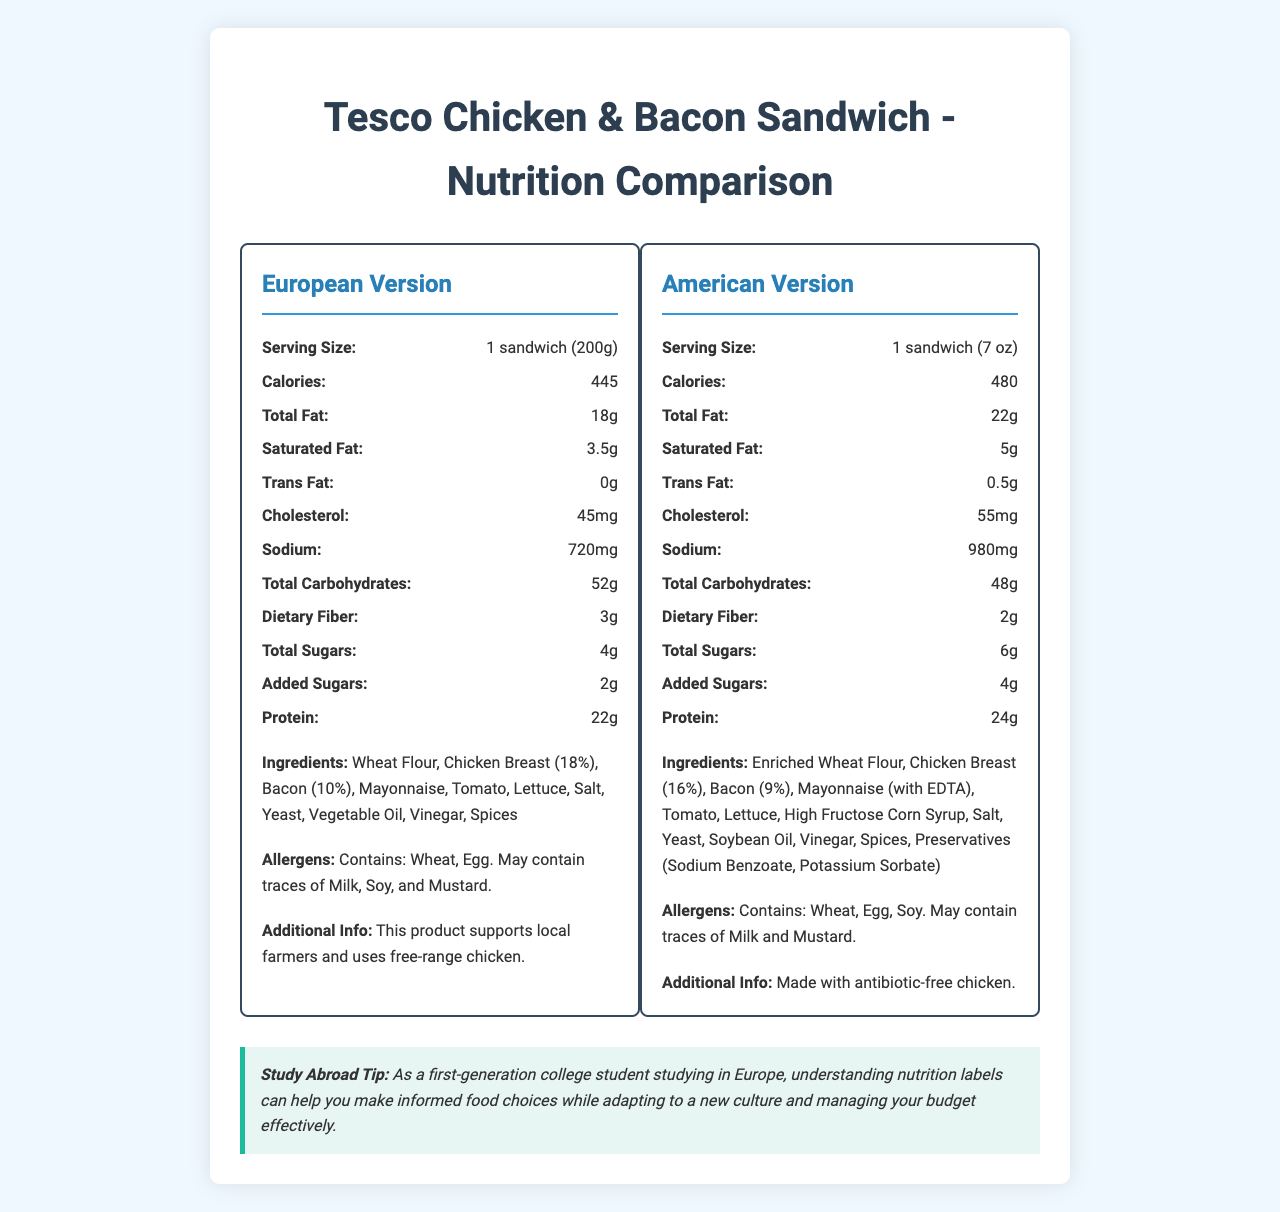what is the serving size for the European version of the sandwich? The serving size for the European version is clearly listed as "1 sandwich (200g)" in the document.
Answer: 1 sandwich (200g) what is the protein content in the American version? The nutrition facts for the American version indicate that it contains 24g of protein.
Answer: 24g how much sodium does the European sandwich have compared to the American sandwich? The nutrition labels show that the European version has 720mg of sodium, whereas the American version has 980mg of sodium.
Answer: The European sandwich has 720mg, while the American sandwich has 980mg. which version has a higher total fat content and by how much? The American version has 22g of total fat, while the European version has 18g, making the American version higher by 4g.
Answer: The American version has 4g more total fat. what are the allergens in the American version? The allergens listed for the American version are Wheat, Egg, and Soy. It may also contain traces of Milk and Mustard.
Answer: Contains: Wheat, Egg, Soy. May contain traces of Milk and Mustard. which version has more added sugars? A. European B. American C. Both have the same The American version has 4g of added sugars, while the European version has 2g.
Answer: B. American what is the price difference between the European and American versions? A. €1.49 B. €2.49 C. $1.49 D. $2.49 The European version is €3.50, and the American version is $4.99. Considering the exchange rate for Euros to USD, the difference can be approximately €1.49.
Answer: A. €1.49 does the European version contain trans fat? The document shows that the European version has 0g of trans fat.
Answer: No summarize the main differences in nutritional values between the European and American versions of the sandwich. The American version appears less healthy overall due to higher values in several areas like calories, fats, and sodium. European packaging is also more environmentally friendly.
Answer: The American version generally has higher calories, total fat, saturated fat, trans fat, cholesterol, sodium, total sugars, and added sugars, while the European version has slightly higher total carbohydrates, dietary fiber, and protein. Additionally, the American version has more preservatives and different packaging materials, whereas the European version supports local farmers and uses free-range chicken. how many grams of dietary fiber does the European sandwich contain? The European sandwich contains 3g of dietary fiber, as listed in the document.
Answer: 3g why might students prefer the European sandwich over the American one? The document does not provide information on preferences or reasons why students might prefer one version over the other. Preferences could vary based on personal taste, health considerations, and other factors not mentioned.
Answer: Cannot be determined 